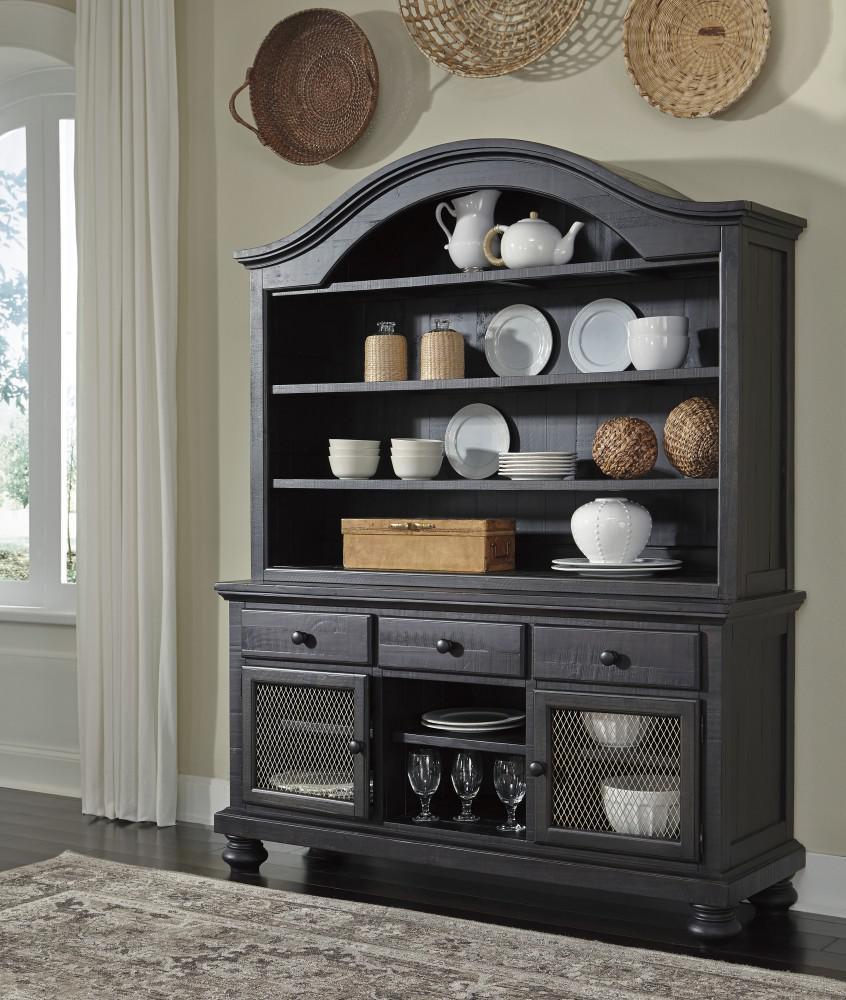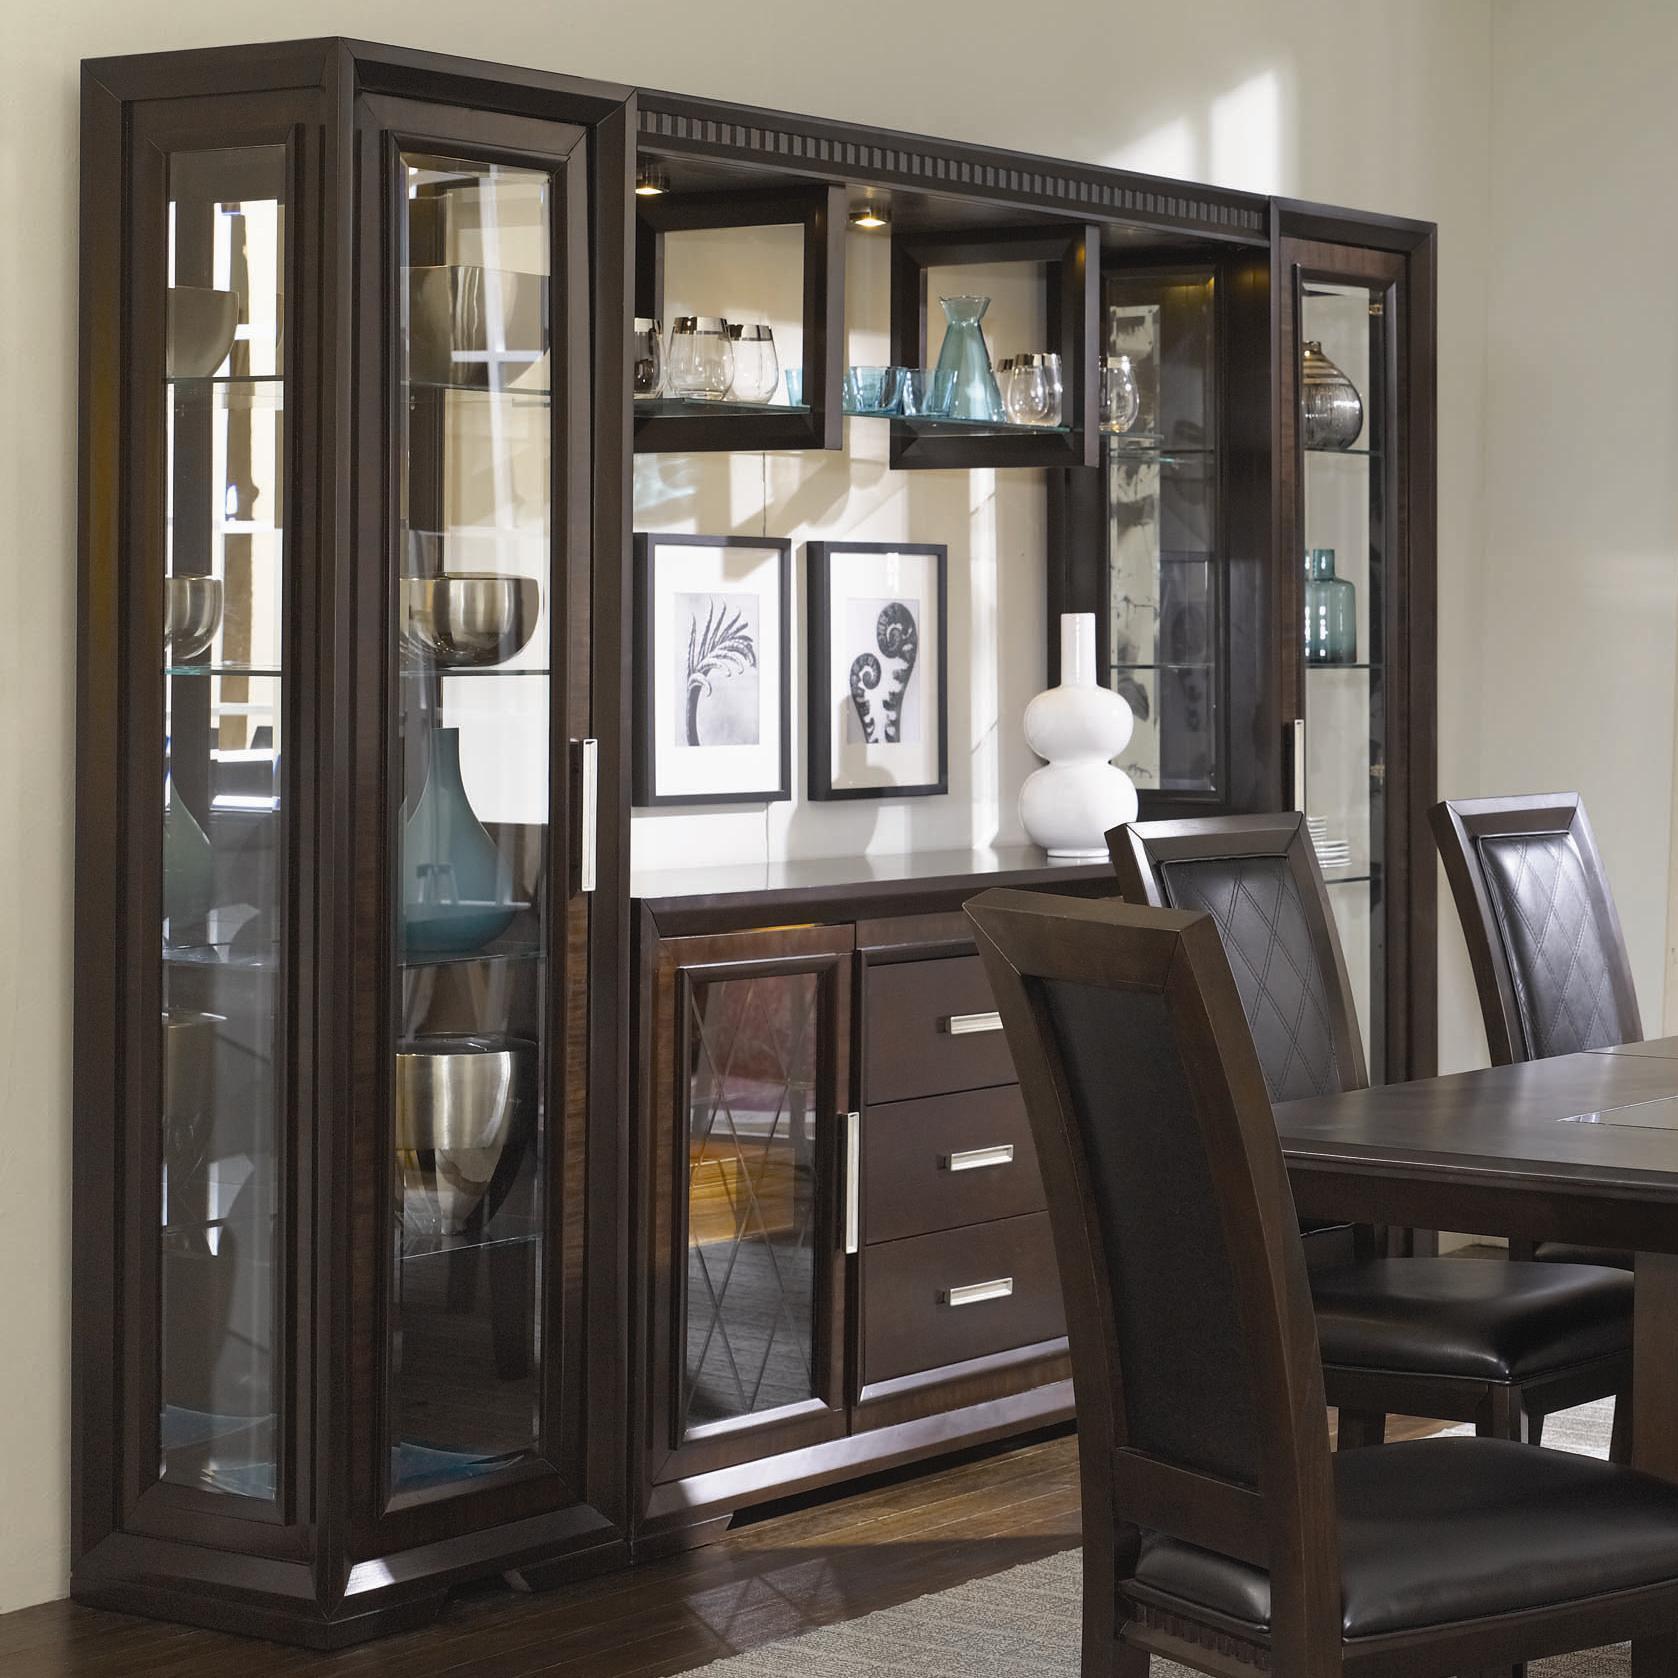The first image is the image on the left, the second image is the image on the right. Analyze the images presented: Is the assertion "Two painted hutches both stand on legs with no glass in the bottom section, but are different colors, and one has a top curve design, while the other is flat on top." valid? Answer yes or no. No. The first image is the image on the left, the second image is the image on the right. For the images shown, is this caption "The cabinet in the left photo has a blue finish." true? Answer yes or no. No. 